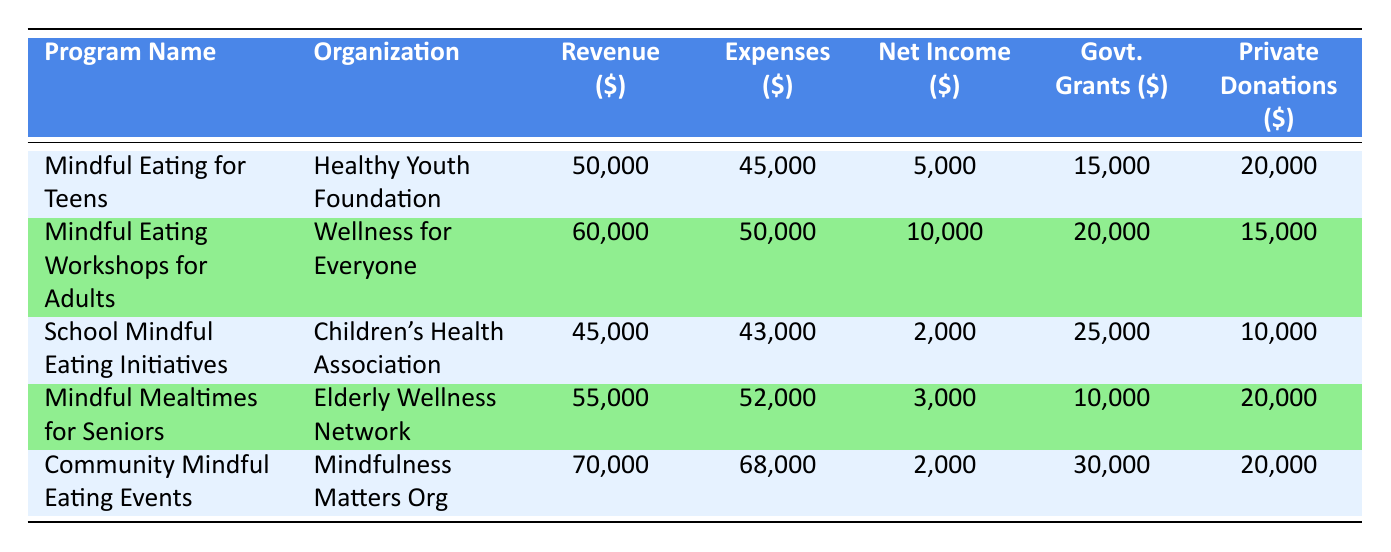What is the net income of the "Mindful Eating for Teens" program? The net income is listed directly in the table under the appropriate program name. For "Mindful Eating for Teens," the net income is stated as 5,000 dollars.
Answer: 5,000 Which program had the highest revenue? Comparing the revenue figures from each program, "Community Mindful Eating Events" has the highest revenue at 70,000 dollars, which is listed in the Revenue column.
Answer: 70,000 Is there a program with more expenses than revenue? To find this, I compare the Expenses and Revenue columns for each program. "Community Mindful Eating Events" shows expenses of 68,000 dollars against revenue of 70,000 dollars, indicating that it is not in this category. However, the analysis reveals that there are no programs with expenses exceeding their revenue. Thus, the answer is based on the overall comparison.
Answer: No What is the total net income of all programs combined? The net income for each program is listed and needs to be summed up: 5,000 + 10,000 + 2,000 + 3,000 + 2,000 = 22,000 dollars. This can be confirmed by adding these figures together.
Answer: 22,000 Did the "Mindful Mealtimes for Seniors" program receive more in government grants than the "Mindful Eating Workshops for Adults" program? The government grants for "Mindful Mealtimes for Seniors" are listed as 10,000 dollars, while for "Mindful Eating Workshops for Adults," they are 20,000 dollars. Comparing these values confirms the answer.
Answer: No What is the average revenue of the programs listed? The revenue amounts are 50,000; 60,000; 45,000; 55,000; and 70,000 dollars. There are 5 programs total. Summing these values gives 280,000 dollars, and dividing by 5 for the average results in 56,000 dollars.
Answer: 56,000 Which organization spent the most on staff salaries? By comparing the Staff Salaries column, "Community Mindful Eating Events," which lists staff salaries as 35,000 dollars, has the highest expenditure in this category.
Answer: Mindfulness Matters Org What is the difference in net income between "Mindful Eating Workshops for Adults" and "School Mindful Eating Initiatives"? The net income for "Mindful Eating Workshops for Adults" is 10,000 dollars and for "School Mindful Eating Initiatives," it is 2,000 dollars. The difference is calculated by subtracting 2,000 from 10,000, resulting in 8,000 dollars.
Answer: 8,000 Did "Children's Health Association" generate a revenue of less than 50,000 dollars? The table indicates that "Children's Health Association" generated 45,000 dollars in revenue. This is indeed less than 50,000 dollars, confirming the response.
Answer: Yes 